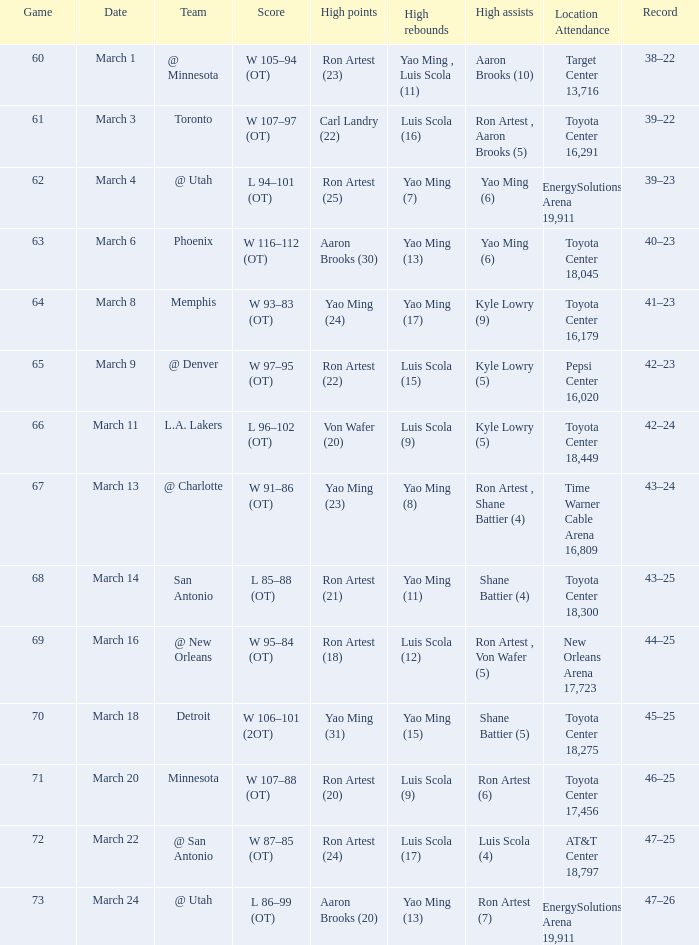On what date did the Rockets play Memphis? March 8. 